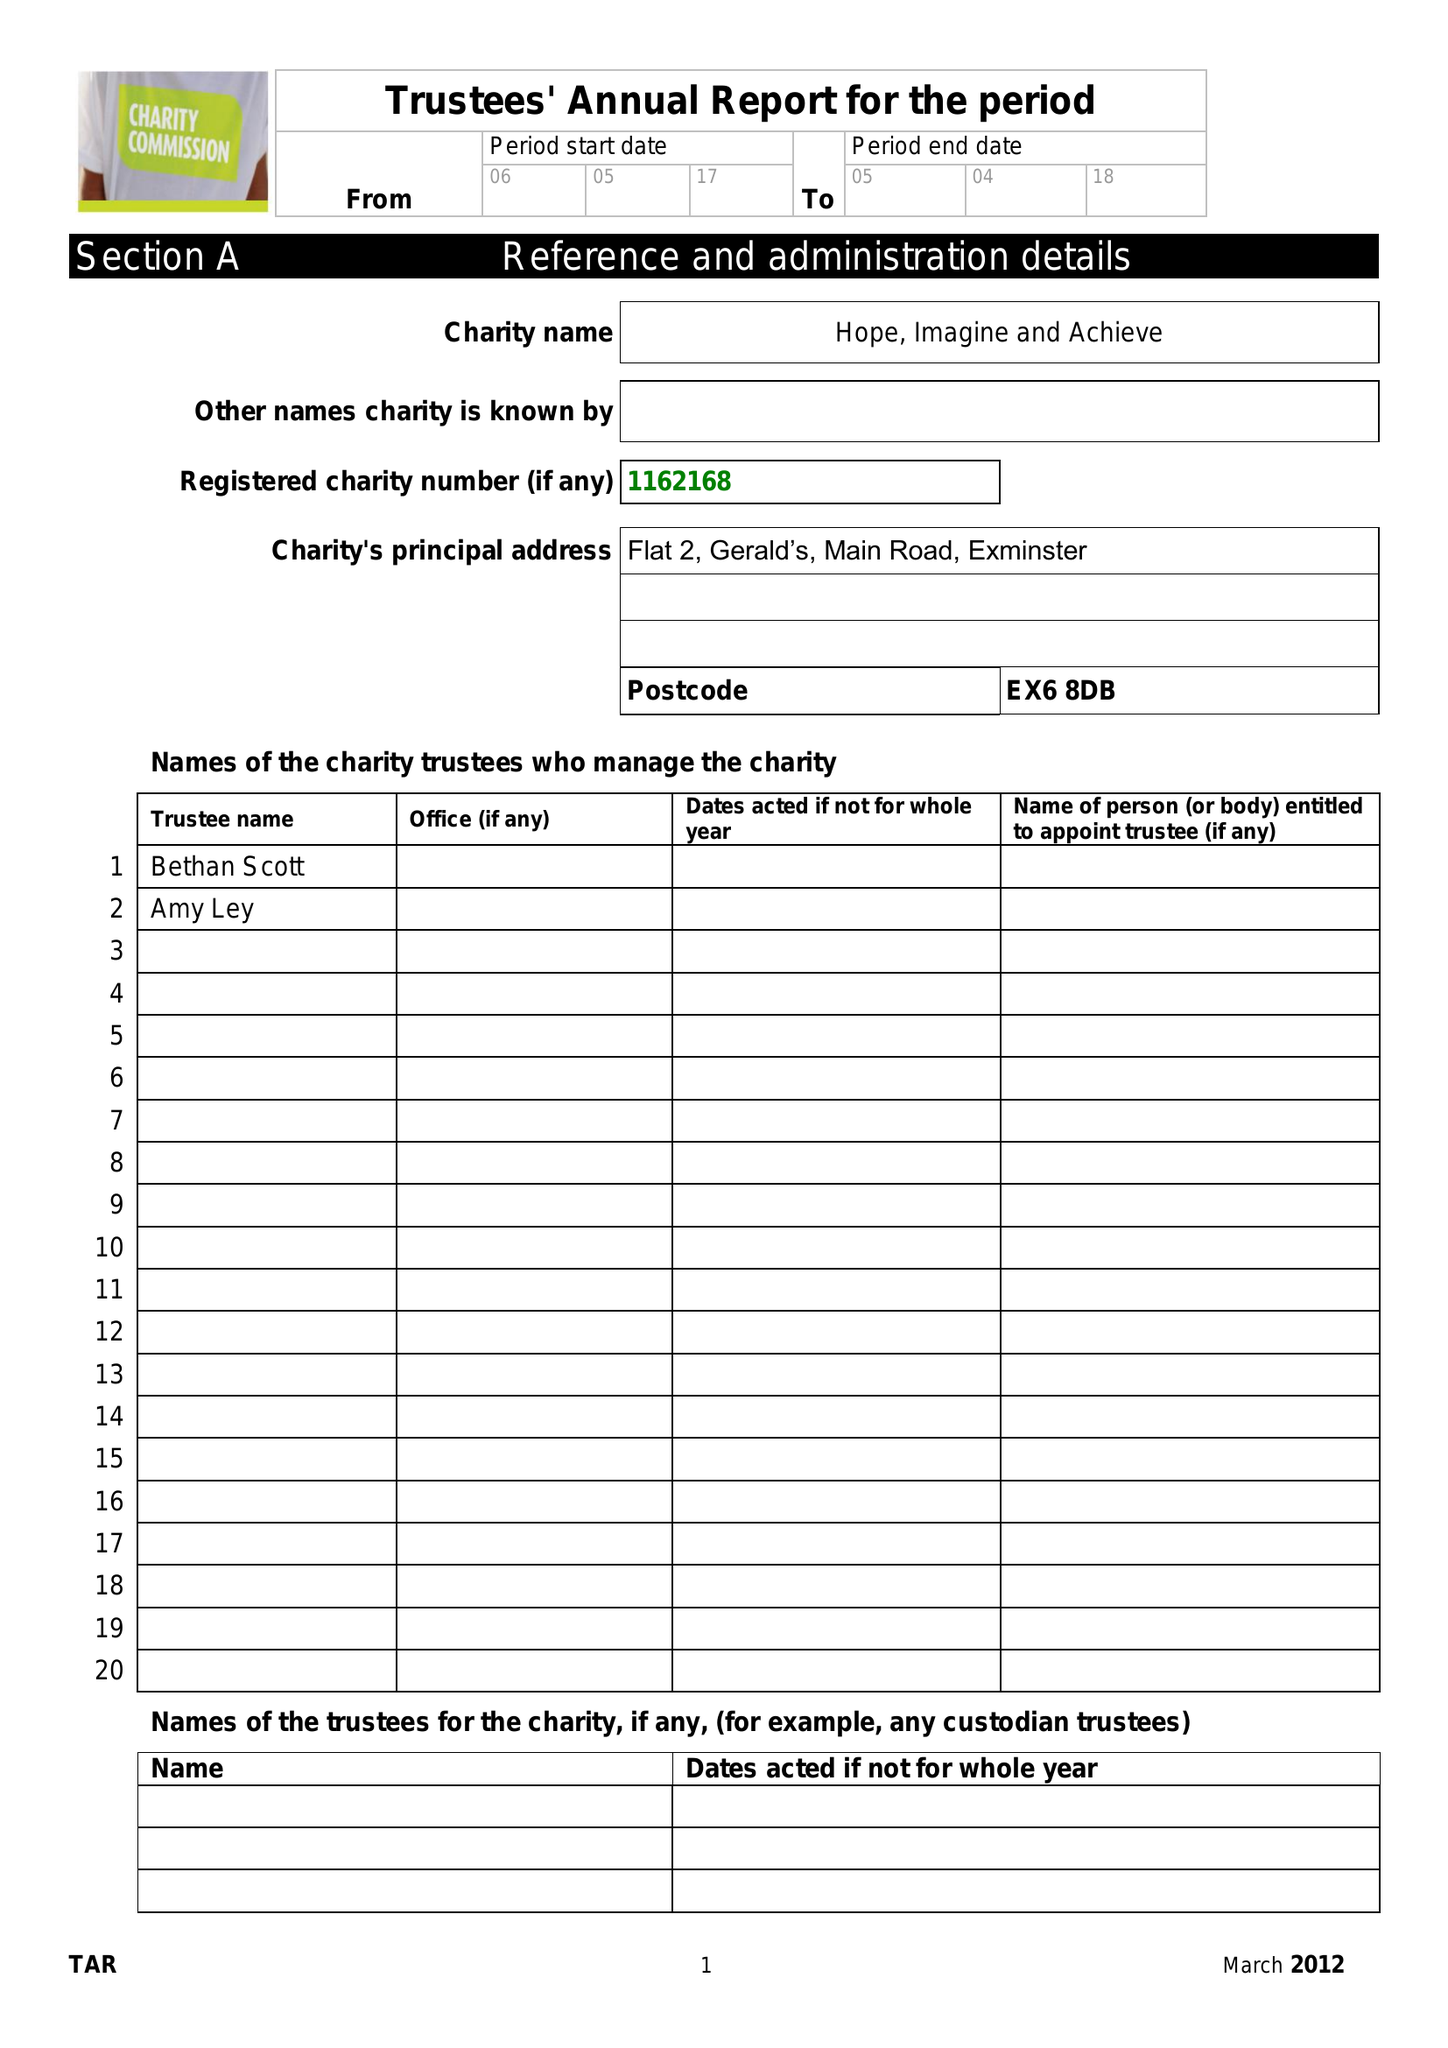What is the value for the spending_annually_in_british_pounds?
Answer the question using a single word or phrase. 3395.00 